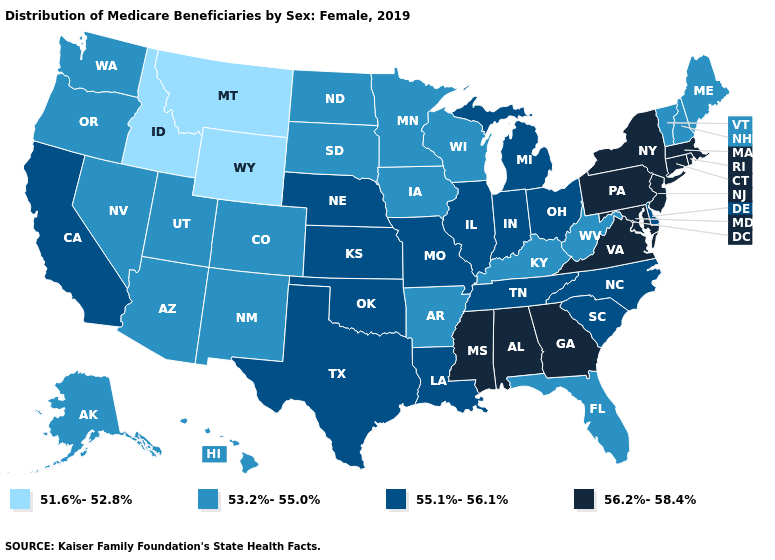Name the states that have a value in the range 56.2%-58.4%?
Be succinct. Alabama, Connecticut, Georgia, Maryland, Massachusetts, Mississippi, New Jersey, New York, Pennsylvania, Rhode Island, Virginia. What is the value of Arkansas?
Write a very short answer. 53.2%-55.0%. Which states have the lowest value in the USA?
Write a very short answer. Idaho, Montana, Wyoming. Which states have the lowest value in the USA?
Keep it brief. Idaho, Montana, Wyoming. Which states have the lowest value in the USA?
Keep it brief. Idaho, Montana, Wyoming. Name the states that have a value in the range 51.6%-52.8%?
Be succinct. Idaho, Montana, Wyoming. Name the states that have a value in the range 55.1%-56.1%?
Short answer required. California, Delaware, Illinois, Indiana, Kansas, Louisiana, Michigan, Missouri, Nebraska, North Carolina, Ohio, Oklahoma, South Carolina, Tennessee, Texas. Does the map have missing data?
Concise answer only. No. What is the lowest value in the MidWest?
Quick response, please. 53.2%-55.0%. Name the states that have a value in the range 55.1%-56.1%?
Be succinct. California, Delaware, Illinois, Indiana, Kansas, Louisiana, Michigan, Missouri, Nebraska, North Carolina, Ohio, Oklahoma, South Carolina, Tennessee, Texas. Does Minnesota have the same value as Idaho?
Quick response, please. No. Does the first symbol in the legend represent the smallest category?
Quick response, please. Yes. Among the states that border Georgia , which have the highest value?
Concise answer only. Alabama. Does Virginia have the lowest value in the USA?
Concise answer only. No. What is the value of Missouri?
Concise answer only. 55.1%-56.1%. 